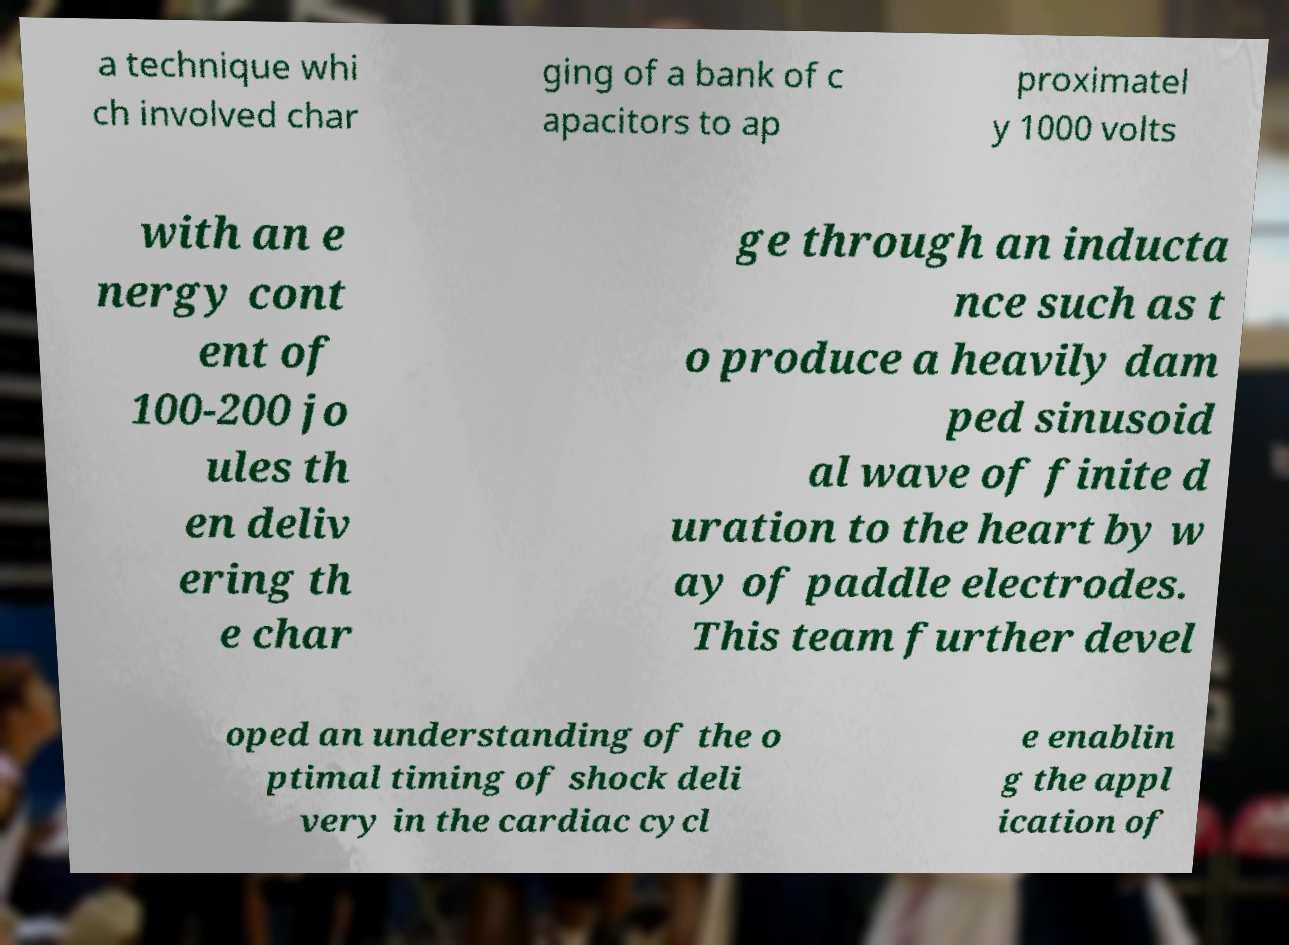I need the written content from this picture converted into text. Can you do that? a technique whi ch involved char ging of a bank of c apacitors to ap proximatel y 1000 volts with an e nergy cont ent of 100-200 jo ules th en deliv ering th e char ge through an inducta nce such as t o produce a heavily dam ped sinusoid al wave of finite d uration to the heart by w ay of paddle electrodes. This team further devel oped an understanding of the o ptimal timing of shock deli very in the cardiac cycl e enablin g the appl ication of 